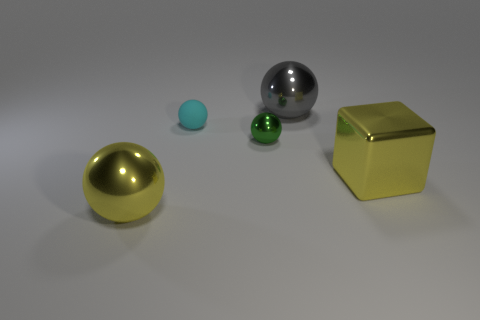There is a yellow thing that is to the right of the gray thing; does it have the same size as the rubber object on the left side of the large gray ball?
Provide a succinct answer. No. There is a metallic ball that is behind the green metallic sphere behind the yellow object that is to the left of the small cyan rubber object; how big is it?
Ensure brevity in your answer.  Large. What is the shape of the yellow metal object on the left side of the big sphere that is behind the yellow metallic thing that is left of the matte sphere?
Your answer should be very brief. Sphere. The large object on the left side of the small green sphere has what shape?
Provide a short and direct response. Sphere. Is the tiny green sphere made of the same material as the object in front of the large yellow shiny block?
Provide a succinct answer. Yes. What number of other objects are there of the same shape as the tiny cyan thing?
Keep it short and to the point. 3. Does the cube have the same color as the large ball that is behind the big cube?
Offer a terse response. No. Are there any other things that are the same material as the green sphere?
Provide a short and direct response. Yes. What is the shape of the yellow shiny object behind the big yellow shiny thing on the left side of the gray thing?
Give a very brief answer. Cube. The sphere that is the same color as the block is what size?
Your answer should be compact. Large. 